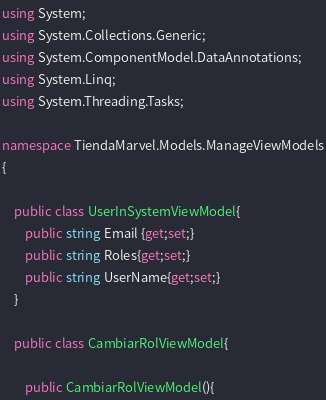Convert code to text. <code><loc_0><loc_0><loc_500><loc_500><_C#_>using System;
using System.Collections.Generic;
using System.ComponentModel.DataAnnotations;
using System.Linq;
using System.Threading.Tasks;

namespace TiendaMarvel.Models.ManageViewModels
{

    public class UserInSystemViewModel{
        public string Email {get;set;}
        public string Roles{get;set;}
        public string UserName{get;set;}
    }

    public class CambiarRolViewModel{
        
        public CambiarRolViewModel(){</code> 